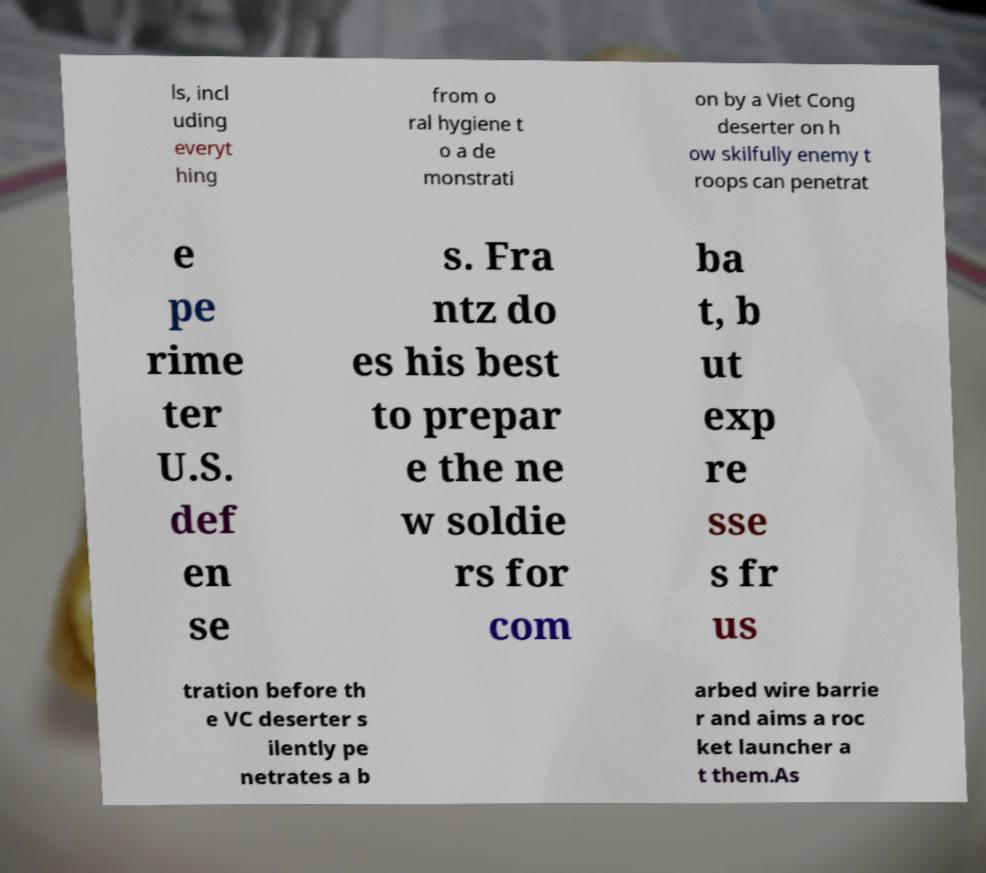What messages or text are displayed in this image? I need them in a readable, typed format. ls, incl uding everyt hing from o ral hygiene t o a de monstrati on by a Viet Cong deserter on h ow skilfully enemy t roops can penetrat e pe rime ter U.S. def en se s. Fra ntz do es his best to prepar e the ne w soldie rs for com ba t, b ut exp re sse s fr us tration before th e VC deserter s ilently pe netrates a b arbed wire barrie r and aims a roc ket launcher a t them.As 